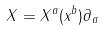<formula> <loc_0><loc_0><loc_500><loc_500>X = X ^ { a } ( x ^ { b } ) \partial _ { a }</formula> 